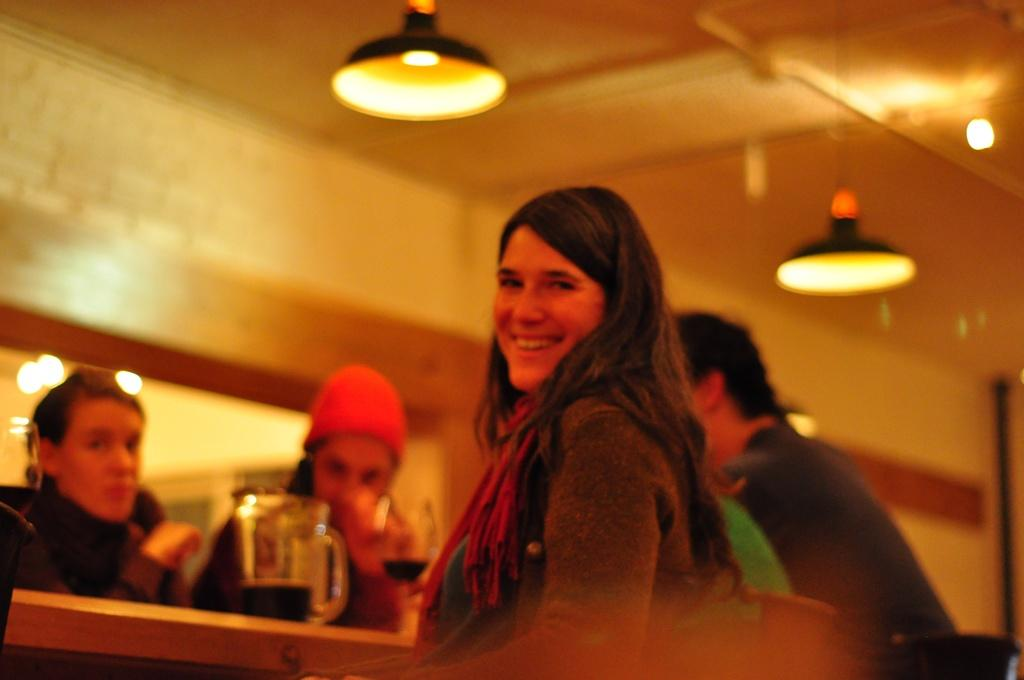How many people are in the image? There is a group of people in the image, but the exact number is not specified. What are the people wearing? The people are wearing different color dresses. What object is on the table in front of the people? There is a jug on a table in front of the people. What can be seen at the top of the image? There are lights visible at the top of the image. What is the caption written below the image? There is no caption written below the image; the provided facts only describe the contents of the image itself. 